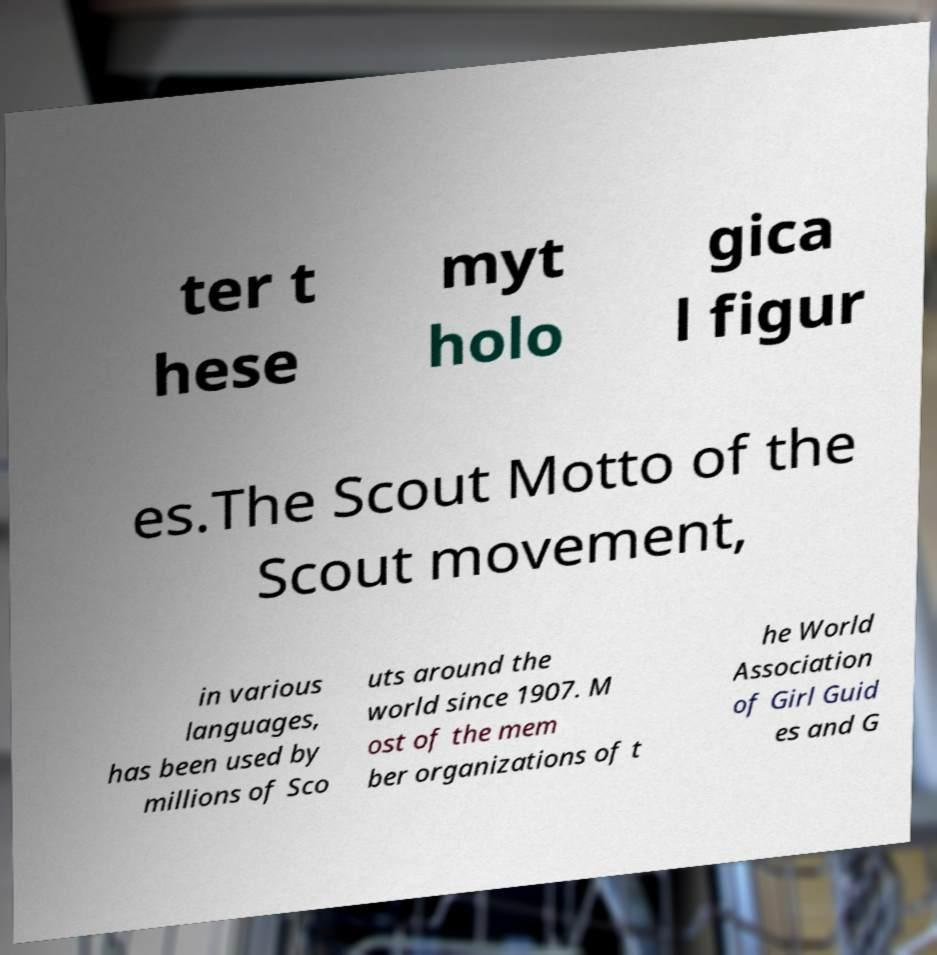Can you read and provide the text displayed in the image?This photo seems to have some interesting text. Can you extract and type it out for me? ter t hese myt holo gica l figur es.The Scout Motto of the Scout movement, in various languages, has been used by millions of Sco uts around the world since 1907. M ost of the mem ber organizations of t he World Association of Girl Guid es and G 